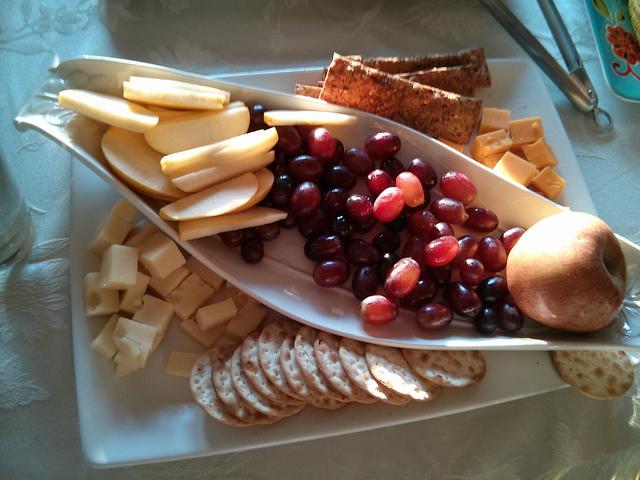How many crackers are shown?
Give a very brief answer. 12. What is the purple fruit?
Give a very brief answer. Grapes. Is this a party snack?
Short answer required. Yes. 